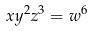<formula> <loc_0><loc_0><loc_500><loc_500>x y ^ { 2 } z ^ { 3 } = w ^ { 6 }</formula> 